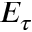<formula> <loc_0><loc_0><loc_500><loc_500>E _ { \tau }</formula> 